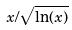Convert formula to latex. <formula><loc_0><loc_0><loc_500><loc_500>x / \sqrt { \ln ( x ) }</formula> 